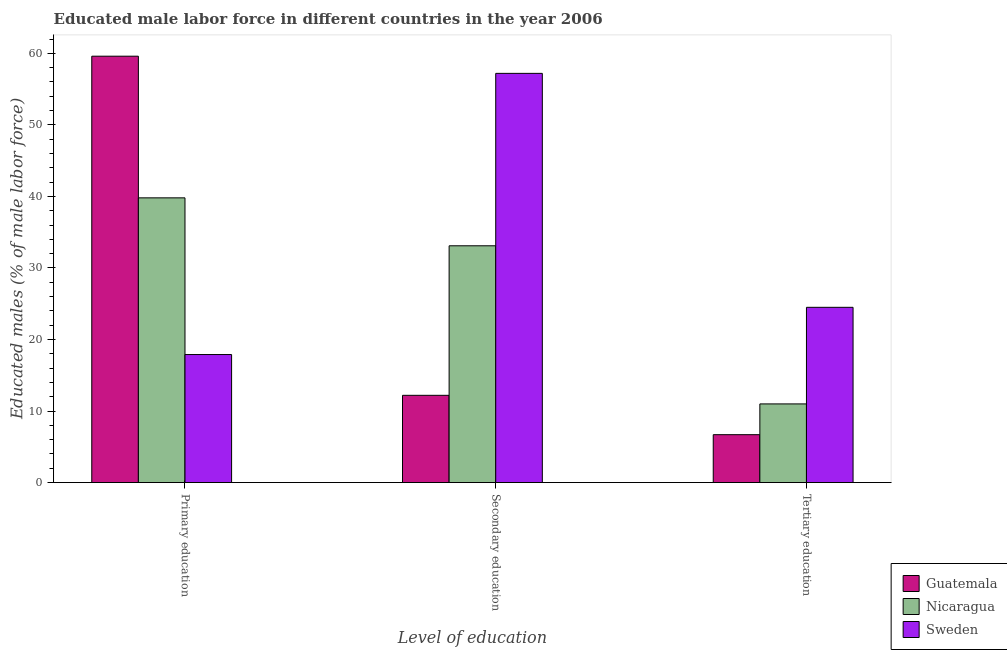How many different coloured bars are there?
Provide a succinct answer. 3. How many groups of bars are there?
Your answer should be very brief. 3. Are the number of bars on each tick of the X-axis equal?
Provide a short and direct response. Yes. How many bars are there on the 3rd tick from the right?
Offer a terse response. 3. What is the label of the 1st group of bars from the left?
Offer a very short reply. Primary education. Across all countries, what is the maximum percentage of male labor force who received secondary education?
Ensure brevity in your answer.  57.2. Across all countries, what is the minimum percentage of male labor force who received tertiary education?
Make the answer very short. 6.7. In which country was the percentage of male labor force who received tertiary education maximum?
Offer a terse response. Sweden. What is the total percentage of male labor force who received secondary education in the graph?
Your answer should be compact. 102.5. What is the difference between the percentage of male labor force who received primary education in Guatemala and that in Sweden?
Your answer should be very brief. 41.7. What is the difference between the percentage of male labor force who received tertiary education in Sweden and the percentage of male labor force who received primary education in Nicaragua?
Your answer should be very brief. -15.3. What is the average percentage of male labor force who received primary education per country?
Keep it short and to the point. 39.1. What is the difference between the percentage of male labor force who received primary education and percentage of male labor force who received secondary education in Sweden?
Make the answer very short. -39.3. What is the ratio of the percentage of male labor force who received tertiary education in Sweden to that in Guatemala?
Your response must be concise. 3.66. What is the difference between the highest and the second highest percentage of male labor force who received secondary education?
Provide a short and direct response. 24.1. What is the difference between the highest and the lowest percentage of male labor force who received secondary education?
Make the answer very short. 45. Is the sum of the percentage of male labor force who received primary education in Guatemala and Nicaragua greater than the maximum percentage of male labor force who received tertiary education across all countries?
Keep it short and to the point. Yes. What does the 1st bar from the left in Primary education represents?
Your response must be concise. Guatemala. What does the 2nd bar from the right in Secondary education represents?
Keep it short and to the point. Nicaragua. Is it the case that in every country, the sum of the percentage of male labor force who received primary education and percentage of male labor force who received secondary education is greater than the percentage of male labor force who received tertiary education?
Provide a short and direct response. Yes. Are all the bars in the graph horizontal?
Provide a short and direct response. No. How many countries are there in the graph?
Ensure brevity in your answer.  3. What is the difference between two consecutive major ticks on the Y-axis?
Ensure brevity in your answer.  10. Does the graph contain grids?
Your response must be concise. No. How are the legend labels stacked?
Provide a succinct answer. Vertical. What is the title of the graph?
Provide a short and direct response. Educated male labor force in different countries in the year 2006. Does "Sierra Leone" appear as one of the legend labels in the graph?
Keep it short and to the point. No. What is the label or title of the X-axis?
Make the answer very short. Level of education. What is the label or title of the Y-axis?
Your response must be concise. Educated males (% of male labor force). What is the Educated males (% of male labor force) of Guatemala in Primary education?
Your answer should be compact. 59.6. What is the Educated males (% of male labor force) in Nicaragua in Primary education?
Keep it short and to the point. 39.8. What is the Educated males (% of male labor force) in Sweden in Primary education?
Your response must be concise. 17.9. What is the Educated males (% of male labor force) of Guatemala in Secondary education?
Your response must be concise. 12.2. What is the Educated males (% of male labor force) in Nicaragua in Secondary education?
Offer a very short reply. 33.1. What is the Educated males (% of male labor force) of Sweden in Secondary education?
Ensure brevity in your answer.  57.2. What is the Educated males (% of male labor force) in Guatemala in Tertiary education?
Provide a succinct answer. 6.7. What is the Educated males (% of male labor force) in Sweden in Tertiary education?
Provide a short and direct response. 24.5. Across all Level of education, what is the maximum Educated males (% of male labor force) of Guatemala?
Make the answer very short. 59.6. Across all Level of education, what is the maximum Educated males (% of male labor force) of Nicaragua?
Your answer should be very brief. 39.8. Across all Level of education, what is the maximum Educated males (% of male labor force) in Sweden?
Your response must be concise. 57.2. Across all Level of education, what is the minimum Educated males (% of male labor force) in Guatemala?
Make the answer very short. 6.7. Across all Level of education, what is the minimum Educated males (% of male labor force) of Nicaragua?
Ensure brevity in your answer.  11. Across all Level of education, what is the minimum Educated males (% of male labor force) in Sweden?
Provide a succinct answer. 17.9. What is the total Educated males (% of male labor force) in Guatemala in the graph?
Your response must be concise. 78.5. What is the total Educated males (% of male labor force) of Nicaragua in the graph?
Your answer should be very brief. 83.9. What is the total Educated males (% of male labor force) in Sweden in the graph?
Provide a short and direct response. 99.6. What is the difference between the Educated males (% of male labor force) in Guatemala in Primary education and that in Secondary education?
Your answer should be very brief. 47.4. What is the difference between the Educated males (% of male labor force) in Nicaragua in Primary education and that in Secondary education?
Make the answer very short. 6.7. What is the difference between the Educated males (% of male labor force) of Sweden in Primary education and that in Secondary education?
Make the answer very short. -39.3. What is the difference between the Educated males (% of male labor force) of Guatemala in Primary education and that in Tertiary education?
Your response must be concise. 52.9. What is the difference between the Educated males (% of male labor force) in Nicaragua in Primary education and that in Tertiary education?
Your response must be concise. 28.8. What is the difference between the Educated males (% of male labor force) of Sweden in Primary education and that in Tertiary education?
Offer a terse response. -6.6. What is the difference between the Educated males (% of male labor force) in Guatemala in Secondary education and that in Tertiary education?
Give a very brief answer. 5.5. What is the difference between the Educated males (% of male labor force) of Nicaragua in Secondary education and that in Tertiary education?
Provide a short and direct response. 22.1. What is the difference between the Educated males (% of male labor force) in Sweden in Secondary education and that in Tertiary education?
Offer a terse response. 32.7. What is the difference between the Educated males (% of male labor force) of Guatemala in Primary education and the Educated males (% of male labor force) of Nicaragua in Secondary education?
Provide a succinct answer. 26.5. What is the difference between the Educated males (% of male labor force) of Guatemala in Primary education and the Educated males (% of male labor force) of Sweden in Secondary education?
Your answer should be compact. 2.4. What is the difference between the Educated males (% of male labor force) in Nicaragua in Primary education and the Educated males (% of male labor force) in Sweden in Secondary education?
Give a very brief answer. -17.4. What is the difference between the Educated males (% of male labor force) of Guatemala in Primary education and the Educated males (% of male labor force) of Nicaragua in Tertiary education?
Provide a succinct answer. 48.6. What is the difference between the Educated males (% of male labor force) of Guatemala in Primary education and the Educated males (% of male labor force) of Sweden in Tertiary education?
Give a very brief answer. 35.1. What is the difference between the Educated males (% of male labor force) in Nicaragua in Primary education and the Educated males (% of male labor force) in Sweden in Tertiary education?
Offer a very short reply. 15.3. What is the difference between the Educated males (% of male labor force) of Guatemala in Secondary education and the Educated males (% of male labor force) of Sweden in Tertiary education?
Your response must be concise. -12.3. What is the average Educated males (% of male labor force) of Guatemala per Level of education?
Keep it short and to the point. 26.17. What is the average Educated males (% of male labor force) in Nicaragua per Level of education?
Your answer should be compact. 27.97. What is the average Educated males (% of male labor force) of Sweden per Level of education?
Your answer should be compact. 33.2. What is the difference between the Educated males (% of male labor force) in Guatemala and Educated males (% of male labor force) in Nicaragua in Primary education?
Your answer should be compact. 19.8. What is the difference between the Educated males (% of male labor force) of Guatemala and Educated males (% of male labor force) of Sweden in Primary education?
Provide a short and direct response. 41.7. What is the difference between the Educated males (% of male labor force) in Nicaragua and Educated males (% of male labor force) in Sweden in Primary education?
Your response must be concise. 21.9. What is the difference between the Educated males (% of male labor force) of Guatemala and Educated males (% of male labor force) of Nicaragua in Secondary education?
Keep it short and to the point. -20.9. What is the difference between the Educated males (% of male labor force) of Guatemala and Educated males (% of male labor force) of Sweden in Secondary education?
Ensure brevity in your answer.  -45. What is the difference between the Educated males (% of male labor force) in Nicaragua and Educated males (% of male labor force) in Sweden in Secondary education?
Your answer should be compact. -24.1. What is the difference between the Educated males (% of male labor force) in Guatemala and Educated males (% of male labor force) in Nicaragua in Tertiary education?
Your answer should be very brief. -4.3. What is the difference between the Educated males (% of male labor force) in Guatemala and Educated males (% of male labor force) in Sweden in Tertiary education?
Offer a very short reply. -17.8. What is the ratio of the Educated males (% of male labor force) of Guatemala in Primary education to that in Secondary education?
Offer a terse response. 4.89. What is the ratio of the Educated males (% of male labor force) of Nicaragua in Primary education to that in Secondary education?
Your answer should be very brief. 1.2. What is the ratio of the Educated males (% of male labor force) in Sweden in Primary education to that in Secondary education?
Make the answer very short. 0.31. What is the ratio of the Educated males (% of male labor force) of Guatemala in Primary education to that in Tertiary education?
Offer a very short reply. 8.9. What is the ratio of the Educated males (% of male labor force) in Nicaragua in Primary education to that in Tertiary education?
Offer a terse response. 3.62. What is the ratio of the Educated males (% of male labor force) in Sweden in Primary education to that in Tertiary education?
Make the answer very short. 0.73. What is the ratio of the Educated males (% of male labor force) in Guatemala in Secondary education to that in Tertiary education?
Offer a terse response. 1.82. What is the ratio of the Educated males (% of male labor force) in Nicaragua in Secondary education to that in Tertiary education?
Give a very brief answer. 3.01. What is the ratio of the Educated males (% of male labor force) in Sweden in Secondary education to that in Tertiary education?
Provide a succinct answer. 2.33. What is the difference between the highest and the second highest Educated males (% of male labor force) in Guatemala?
Keep it short and to the point. 47.4. What is the difference between the highest and the second highest Educated males (% of male labor force) in Sweden?
Offer a terse response. 32.7. What is the difference between the highest and the lowest Educated males (% of male labor force) in Guatemala?
Your response must be concise. 52.9. What is the difference between the highest and the lowest Educated males (% of male labor force) of Nicaragua?
Your answer should be compact. 28.8. What is the difference between the highest and the lowest Educated males (% of male labor force) in Sweden?
Keep it short and to the point. 39.3. 